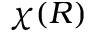Convert formula to latex. <formula><loc_0><loc_0><loc_500><loc_500>\chi ( R )</formula> 